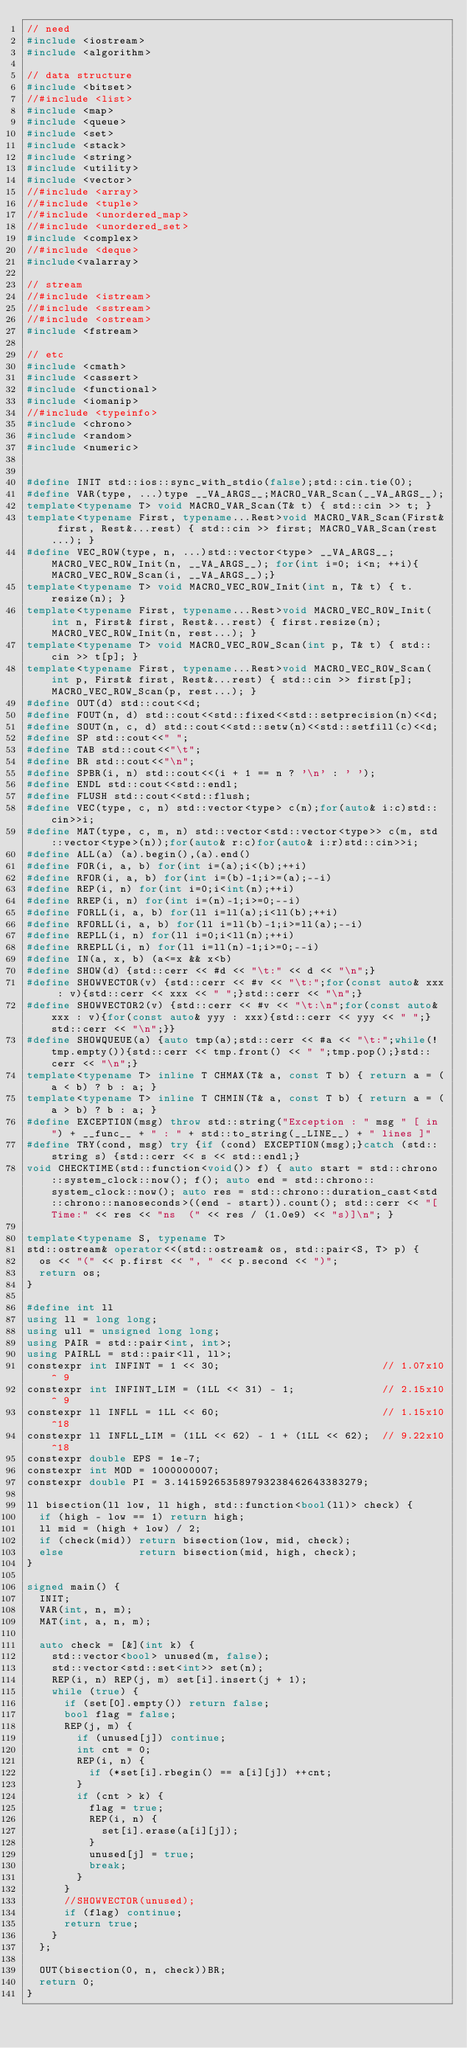<code> <loc_0><loc_0><loc_500><loc_500><_C++_>// need
#include <iostream>
#include <algorithm>

// data structure
#include <bitset>
//#include <list>
#include <map>
#include <queue>
#include <set>
#include <stack>
#include <string>
#include <utility>
#include <vector>
//#include <array>
//#include <tuple>
//#include <unordered_map>
//#include <unordered_set>
#include <complex>
//#include <deque>
#include<valarray>

// stream
//#include <istream>
//#include <sstream>
//#include <ostream>
#include <fstream>

// etc
#include <cmath>
#include <cassert>
#include <functional>
#include <iomanip>
//#include <typeinfo>
#include <chrono>
#include <random>
#include <numeric>


#define INIT std::ios::sync_with_stdio(false);std::cin.tie(0);
#define VAR(type, ...)type __VA_ARGS__;MACRO_VAR_Scan(__VA_ARGS__);
template<typename T> void MACRO_VAR_Scan(T& t) { std::cin >> t; }
template<typename First, typename...Rest>void MACRO_VAR_Scan(First& first, Rest&...rest) { std::cin >> first; MACRO_VAR_Scan(rest...); }
#define VEC_ROW(type, n, ...)std::vector<type> __VA_ARGS__;MACRO_VEC_ROW_Init(n, __VA_ARGS__); for(int i=0; i<n; ++i){MACRO_VEC_ROW_Scan(i, __VA_ARGS__);}
template<typename T> void MACRO_VEC_ROW_Init(int n, T& t) { t.resize(n); }
template<typename First, typename...Rest>void MACRO_VEC_ROW_Init(int n, First& first, Rest&...rest) { first.resize(n); MACRO_VEC_ROW_Init(n, rest...); }
template<typename T> void MACRO_VEC_ROW_Scan(int p, T& t) { std::cin >> t[p]; }
template<typename First, typename...Rest>void MACRO_VEC_ROW_Scan(int p, First& first, Rest&...rest) { std::cin >> first[p]; MACRO_VEC_ROW_Scan(p, rest...); }
#define OUT(d) std::cout<<d;
#define FOUT(n, d) std::cout<<std::fixed<<std::setprecision(n)<<d;
#define SOUT(n, c, d) std::cout<<std::setw(n)<<std::setfill(c)<<d;
#define SP std::cout<<" ";
#define TAB std::cout<<"\t";
#define BR std::cout<<"\n";
#define SPBR(i, n) std::cout<<(i + 1 == n ? '\n' : ' ');
#define ENDL std::cout<<std::endl;
#define FLUSH std::cout<<std::flush;
#define VEC(type, c, n) std::vector<type> c(n);for(auto& i:c)std::cin>>i;
#define MAT(type, c, m, n) std::vector<std::vector<type>> c(m, std::vector<type>(n));for(auto& r:c)for(auto& i:r)std::cin>>i;
#define ALL(a) (a).begin(),(a).end()
#define FOR(i, a, b) for(int i=(a);i<(b);++i)
#define RFOR(i, a, b) for(int i=(b)-1;i>=(a);--i)
#define REP(i, n) for(int i=0;i<int(n);++i)
#define RREP(i, n) for(int i=(n)-1;i>=0;--i)
#define FORLL(i, a, b) for(ll i=ll(a);i<ll(b);++i)
#define RFORLL(i, a, b) for(ll i=ll(b)-1;i>=ll(a);--i)
#define REPLL(i, n) for(ll i=0;i<ll(n);++i)
#define RREPLL(i, n) for(ll i=ll(n)-1;i>=0;--i)
#define IN(a, x, b) (a<=x && x<b)
#define SHOW(d) {std::cerr << #d << "\t:" << d << "\n";}
#define SHOWVECTOR(v) {std::cerr << #v << "\t:";for(const auto& xxx : v){std::cerr << xxx << " ";}std::cerr << "\n";}
#define SHOWVECTOR2(v) {std::cerr << #v << "\t:\n";for(const auto& xxx : v){for(const auto& yyy : xxx){std::cerr << yyy << " ";}std::cerr << "\n";}}
#define SHOWQUEUE(a) {auto tmp(a);std::cerr << #a << "\t:";while(!tmp.empty()){std::cerr << tmp.front() << " ";tmp.pop();}std::cerr << "\n";}
template<typename T> inline T CHMAX(T& a, const T b) { return a = (a < b) ? b : a; }
template<typename T> inline T CHMIN(T& a, const T b) { return a = (a > b) ? b : a; }
#define EXCEPTION(msg) throw std::string("Exception : " msg " [ in ") + __func__ + " : " + std::to_string(__LINE__) + " lines ]"
#define TRY(cond, msg) try {if (cond) EXCEPTION(msg);}catch (std::string s) {std::cerr << s << std::endl;}
void CHECKTIME(std::function<void()> f) { auto start = std::chrono::system_clock::now(); f(); auto end = std::chrono::system_clock::now(); auto res = std::chrono::duration_cast<std::chrono::nanoseconds>((end - start)).count(); std::cerr << "[Time:" << res << "ns  (" << res / (1.0e9) << "s)]\n"; }

template<typename S, typename T>
std::ostream& operator<<(std::ostream& os, std::pair<S, T> p) {
	os << "(" << p.first << ", " << p.second << ")";
	return os;
}

#define int ll
using ll = long long;
using ull = unsigned long long;
using PAIR = std::pair<int, int>;
using PAIRLL = std::pair<ll, ll>;
constexpr int INFINT = 1 << 30;                          // 1.07x10^ 9
constexpr int INFINT_LIM = (1LL << 31) - 1;              // 2.15x10^ 9
constexpr ll INFLL = 1LL << 60;                          // 1.15x10^18
constexpr ll INFLL_LIM = (1LL << 62) - 1 + (1LL << 62);  // 9.22x10^18
constexpr double EPS = 1e-7;
constexpr int MOD = 1000000007;
constexpr double PI = 3.141592653589793238462643383279;

ll bisection(ll low, ll high, std::function<bool(ll)> check) {
	if (high - low == 1) return high;
	ll mid = (high + low) / 2;
	if (check(mid)) return bisection(low, mid, check);
	else            return bisection(mid, high, check);
}

signed main() {
	INIT;
	VAR(int, n, m);
	MAT(int, a, n, m);

	auto check = [&](int k) {
		std::vector<bool> unused(m, false);
		std::vector<std::set<int>> set(n);
		REP(i, n) REP(j, m) set[i].insert(j + 1);
		while (true) {
			if (set[0].empty()) return false;
			bool flag = false;
			REP(j, m) {
				if (unused[j]) continue;
				int cnt = 0;
				REP(i, n) {
					if (*set[i].rbegin() == a[i][j]) ++cnt;
				}
				if (cnt > k) {
					flag = true;
					REP(i, n) {
						set[i].erase(a[i][j]);
					}
					unused[j] = true;
					break;
				}
			}
			//SHOWVECTOR(unused);
			if (flag) continue;
			return true;
		}
	};

	OUT(bisection(0, n, check))BR;
	return 0;
}</code> 